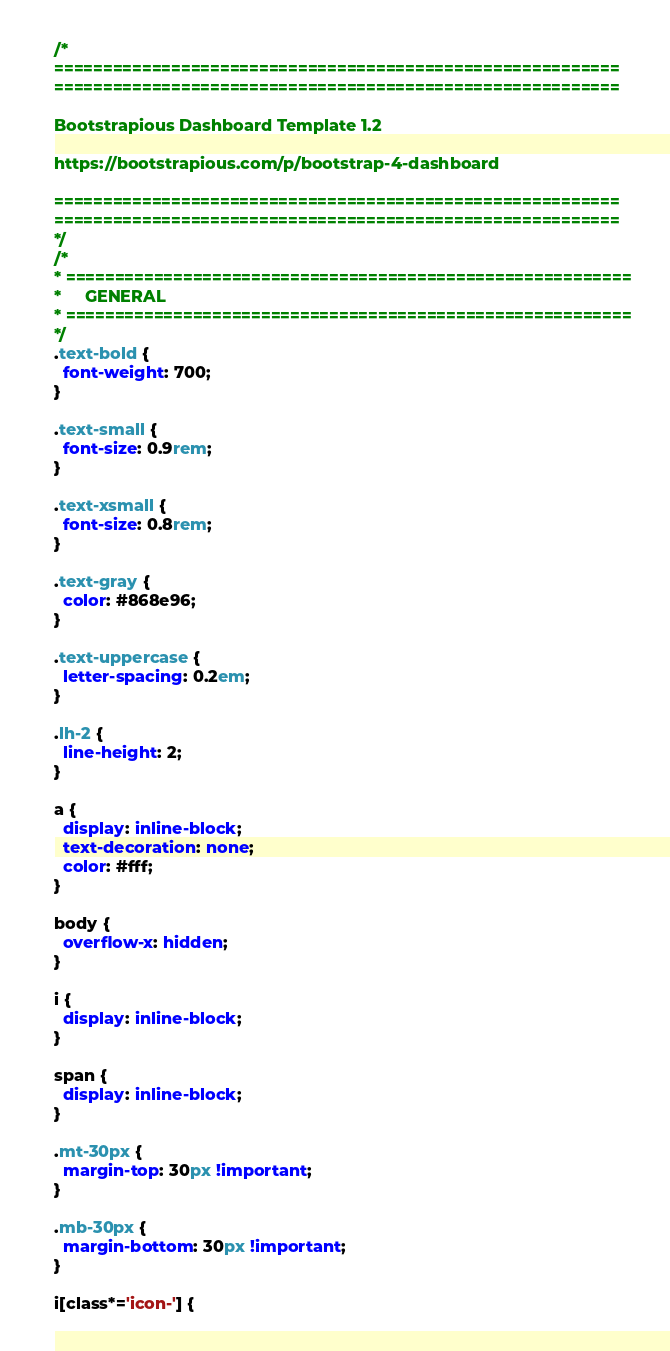Convert code to text. <code><loc_0><loc_0><loc_500><loc_500><_CSS_>/*
==========================================================
==========================================================

Bootstrapious Dashboard Template 1.2

https://bootstrapious.com/p/bootstrap-4-dashboard

==========================================================
==========================================================
*/
/*
* ==========================================================
*     GENERAL
* ==========================================================
*/
.text-bold {
  font-weight: 700;
}

.text-small {
  font-size: 0.9rem;
}

.text-xsmall {
  font-size: 0.8rem;
}

.text-gray {
  color: #868e96;
}

.text-uppercase {
  letter-spacing: 0.2em;
}

.lh-2 {
  line-height: 2;
}

a {
  display: inline-block;
  text-decoration: none;
  color: #fff;
}

body {
  overflow-x: hidden;
}

i {
  display: inline-block;
}

span {
  display: inline-block;
}

.mt-30px {
  margin-top: 30px !important;
}

.mb-30px {
  margin-bottom: 30px !important;
}

i[class*='icon-'] {</code> 